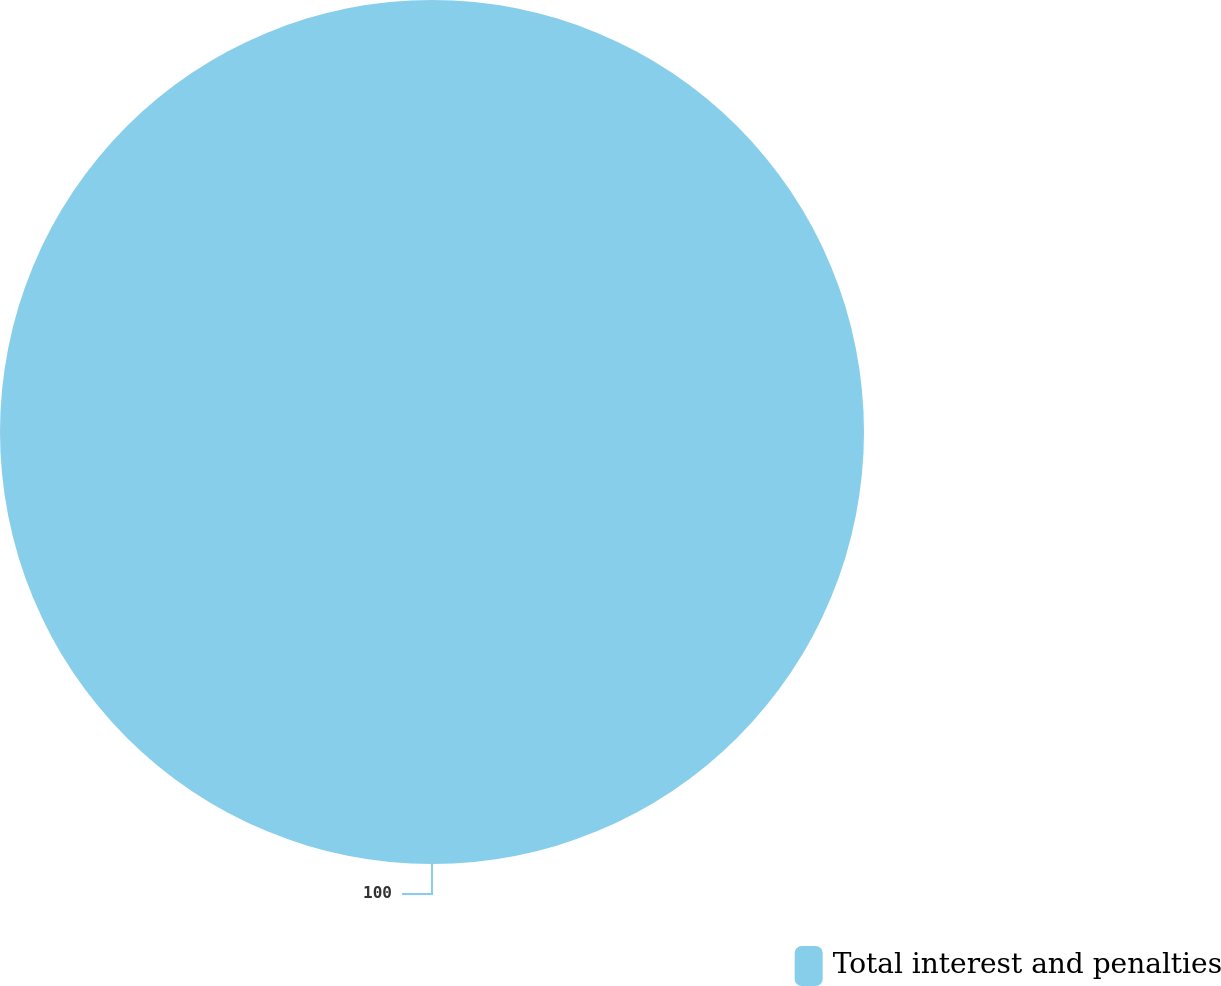Convert chart. <chart><loc_0><loc_0><loc_500><loc_500><pie_chart><fcel>Total interest and penalties<nl><fcel>100.0%<nl></chart> 